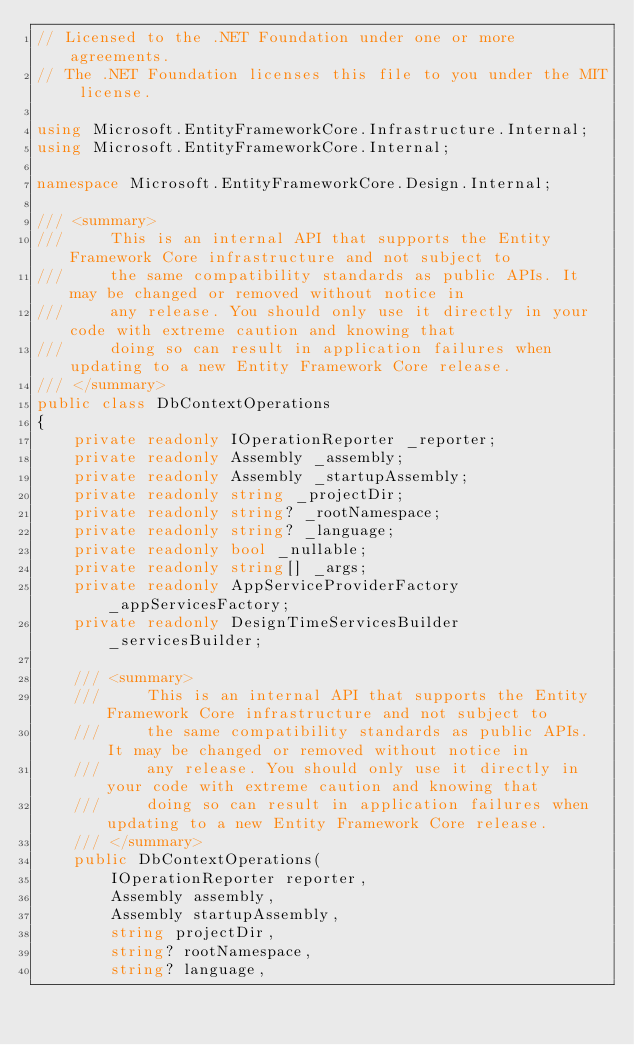<code> <loc_0><loc_0><loc_500><loc_500><_C#_>// Licensed to the .NET Foundation under one or more agreements.
// The .NET Foundation licenses this file to you under the MIT license.

using Microsoft.EntityFrameworkCore.Infrastructure.Internal;
using Microsoft.EntityFrameworkCore.Internal;

namespace Microsoft.EntityFrameworkCore.Design.Internal;

/// <summary>
///     This is an internal API that supports the Entity Framework Core infrastructure and not subject to
///     the same compatibility standards as public APIs. It may be changed or removed without notice in
///     any release. You should only use it directly in your code with extreme caution and knowing that
///     doing so can result in application failures when updating to a new Entity Framework Core release.
/// </summary>
public class DbContextOperations
{
    private readonly IOperationReporter _reporter;
    private readonly Assembly _assembly;
    private readonly Assembly _startupAssembly;
    private readonly string _projectDir;
    private readonly string? _rootNamespace;
    private readonly string? _language;
    private readonly bool _nullable;
    private readonly string[] _args;
    private readonly AppServiceProviderFactory _appServicesFactory;
    private readonly DesignTimeServicesBuilder _servicesBuilder;

    /// <summary>
    ///     This is an internal API that supports the Entity Framework Core infrastructure and not subject to
    ///     the same compatibility standards as public APIs. It may be changed or removed without notice in
    ///     any release. You should only use it directly in your code with extreme caution and knowing that
    ///     doing so can result in application failures when updating to a new Entity Framework Core release.
    /// </summary>
    public DbContextOperations(
        IOperationReporter reporter,
        Assembly assembly,
        Assembly startupAssembly,
        string projectDir,
        string? rootNamespace,
        string? language,</code> 